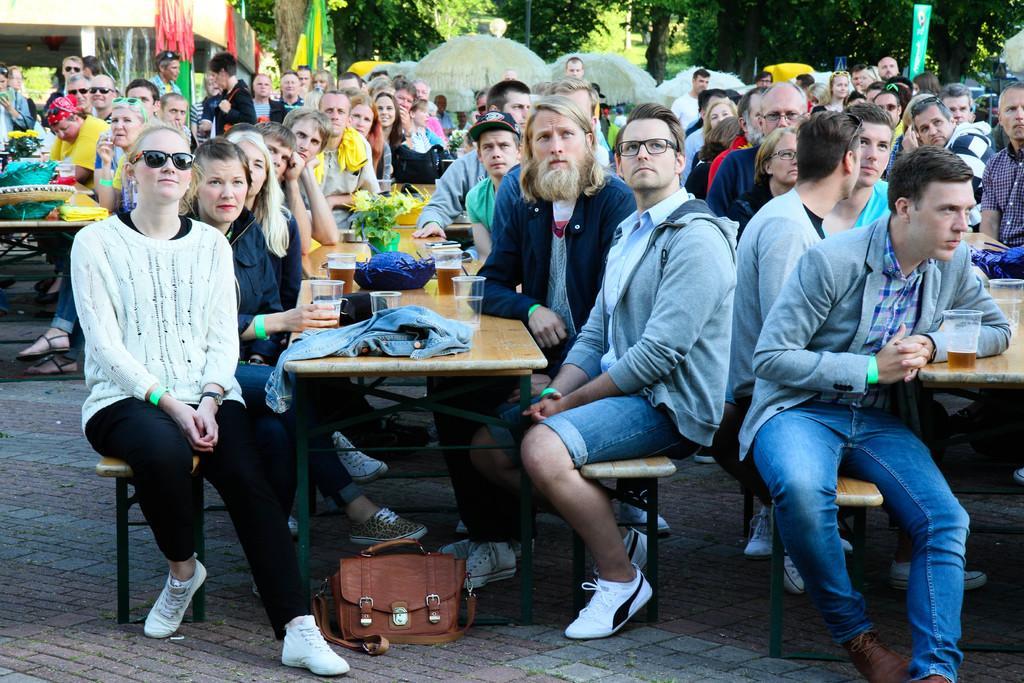Please provide a concise description of this image. In this image I see number of people who are sitting on benches and I see there are tables in front of them on which there are many things. In the background I see the trees. 